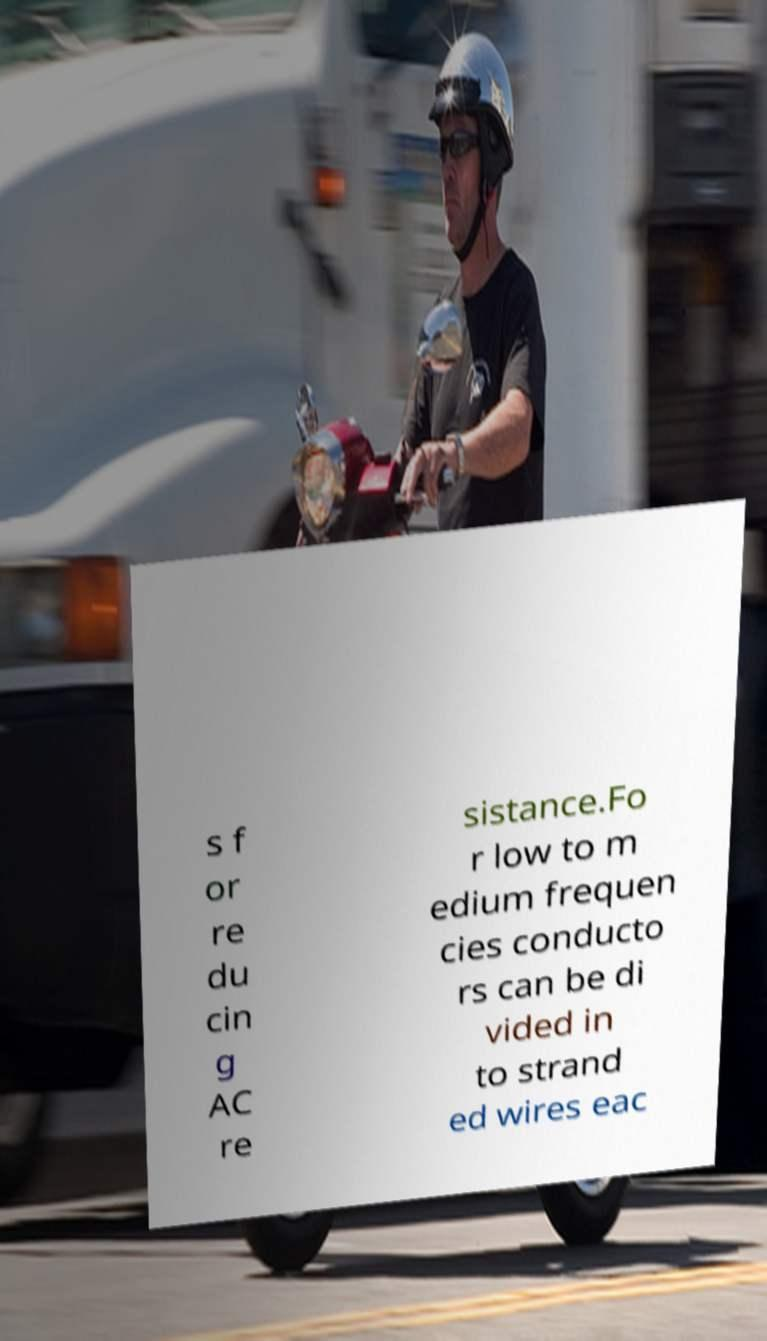What messages or text are displayed in this image? I need them in a readable, typed format. s f or re du cin g AC re sistance.Fo r low to m edium frequen cies conducto rs can be di vided in to strand ed wires eac 